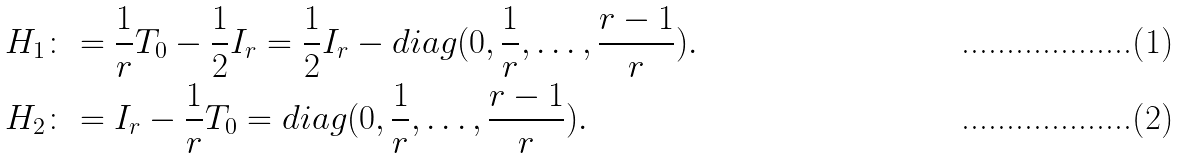Convert formula to latex. <formula><loc_0><loc_0><loc_500><loc_500>H _ { 1 } & \colon = \frac { 1 } { r } T _ { 0 } - \frac { 1 } { 2 } I _ { r } = \frac { 1 } { 2 } I _ { r } - d i a g ( 0 , \frac { 1 } { r } , \dots , \frac { r - 1 } { r } ) . \\ H _ { 2 } & \colon = I _ { r } - \frac { 1 } { r } T _ { 0 } = d i a g ( 0 , \frac { 1 } { r } , \dots , \frac { r - 1 } { r } ) .</formula> 